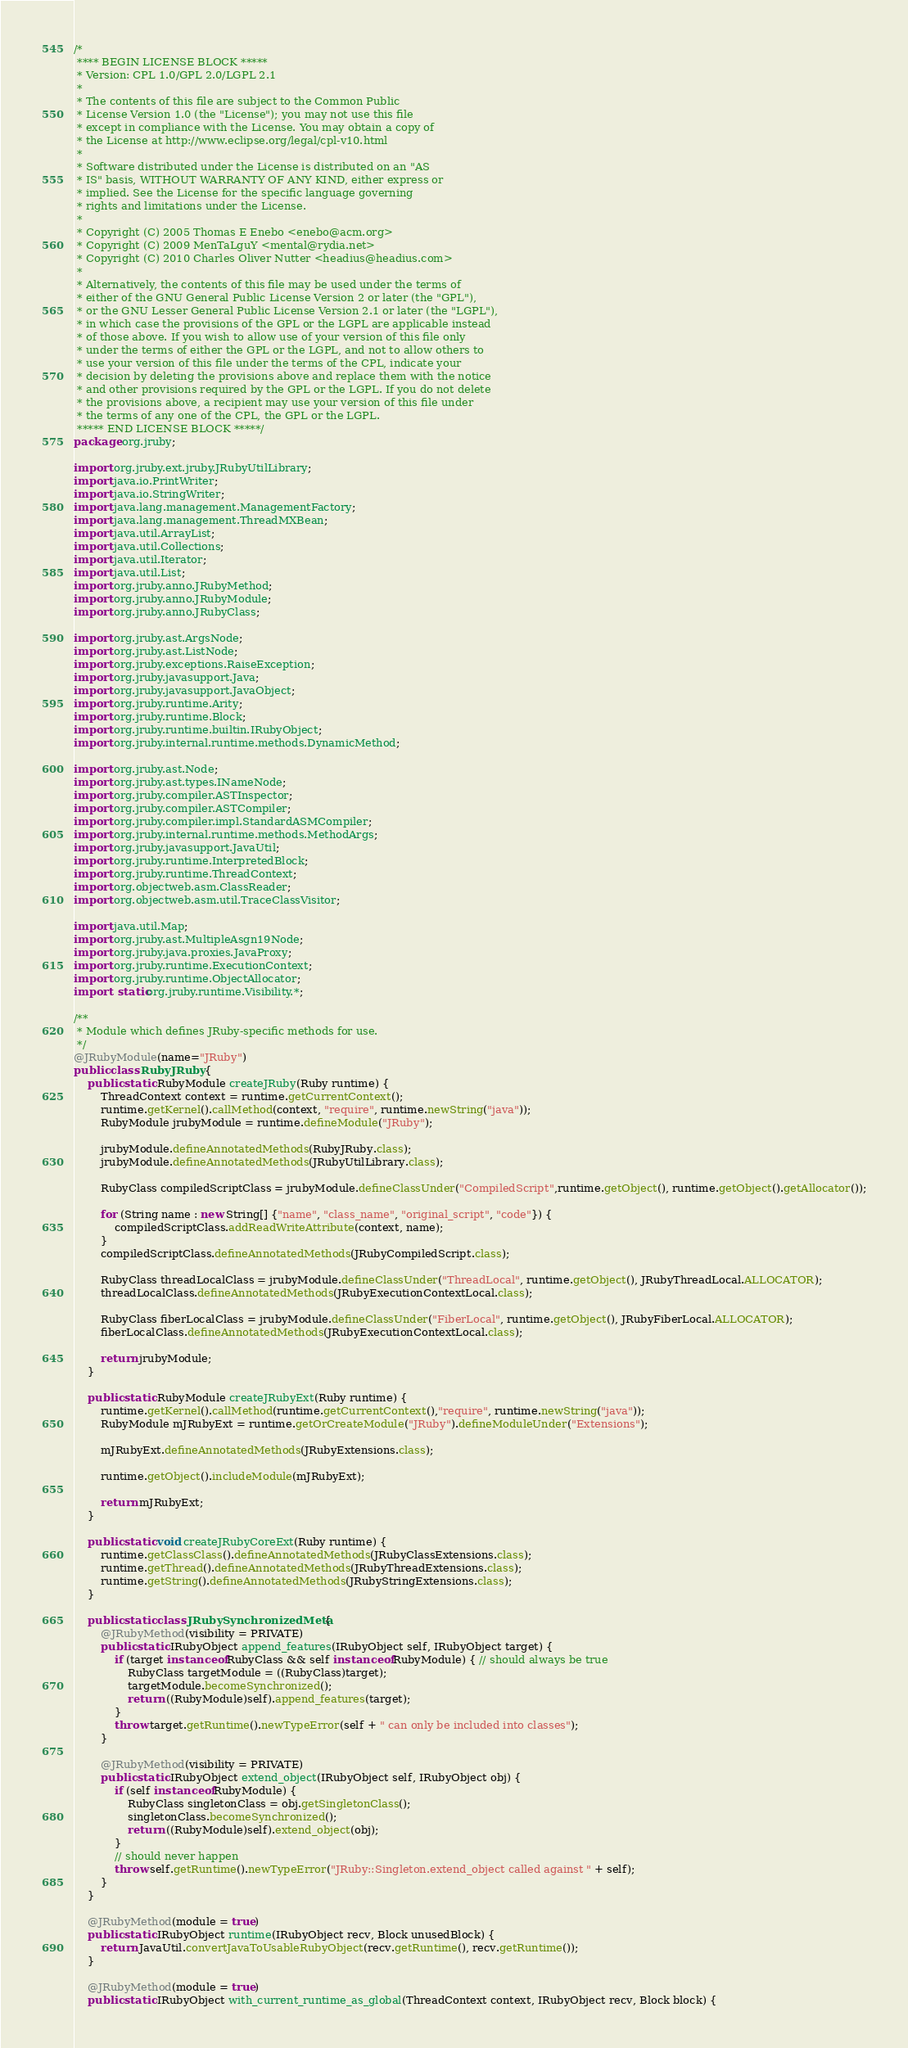Convert code to text. <code><loc_0><loc_0><loc_500><loc_500><_Java_>/*
 **** BEGIN LICENSE BLOCK *****
 * Version: CPL 1.0/GPL 2.0/LGPL 2.1
 *
 * The contents of this file are subject to the Common Public
 * License Version 1.0 (the "License"); you may not use this file
 * except in compliance with the License. You may obtain a copy of
 * the License at http://www.eclipse.org/legal/cpl-v10.html
 *
 * Software distributed under the License is distributed on an "AS
 * IS" basis, WITHOUT WARRANTY OF ANY KIND, either express or
 * implied. See the License for the specific language governing
 * rights and limitations under the License.
 *
 * Copyright (C) 2005 Thomas E Enebo <enebo@acm.org>
 * Copyright (C) 2009 MenTaLguY <mental@rydia.net>
 * Copyright (C) 2010 Charles Oliver Nutter <headius@headius.com>
 * 
 * Alternatively, the contents of this file may be used under the terms of
 * either of the GNU General Public License Version 2 or later (the "GPL"),
 * or the GNU Lesser General Public License Version 2.1 or later (the "LGPL"),
 * in which case the provisions of the GPL or the LGPL are applicable instead
 * of those above. If you wish to allow use of your version of this file only
 * under the terms of either the GPL or the LGPL, and not to allow others to
 * use your version of this file under the terms of the CPL, indicate your
 * decision by deleting the provisions above and replace them with the notice
 * and other provisions required by the GPL or the LGPL. If you do not delete
 * the provisions above, a recipient may use your version of this file under
 * the terms of any one of the CPL, the GPL or the LGPL.
 ***** END LICENSE BLOCK *****/
package org.jruby;

import org.jruby.ext.jruby.JRubyUtilLibrary;
import java.io.PrintWriter;
import java.io.StringWriter;
import java.lang.management.ManagementFactory;
import java.lang.management.ThreadMXBean;
import java.util.ArrayList;
import java.util.Collections;
import java.util.Iterator;
import java.util.List;
import org.jruby.anno.JRubyMethod;
import org.jruby.anno.JRubyModule;
import org.jruby.anno.JRubyClass;

import org.jruby.ast.ArgsNode;
import org.jruby.ast.ListNode;
import org.jruby.exceptions.RaiseException;
import org.jruby.javasupport.Java;
import org.jruby.javasupport.JavaObject;
import org.jruby.runtime.Arity;
import org.jruby.runtime.Block;
import org.jruby.runtime.builtin.IRubyObject;
import org.jruby.internal.runtime.methods.DynamicMethod;

import org.jruby.ast.Node;
import org.jruby.ast.types.INameNode;
import org.jruby.compiler.ASTInspector;
import org.jruby.compiler.ASTCompiler;
import org.jruby.compiler.impl.StandardASMCompiler;
import org.jruby.internal.runtime.methods.MethodArgs;
import org.jruby.javasupport.JavaUtil;
import org.jruby.runtime.InterpretedBlock;
import org.jruby.runtime.ThreadContext;
import org.objectweb.asm.ClassReader;
import org.objectweb.asm.util.TraceClassVisitor;

import java.util.Map;
import org.jruby.ast.MultipleAsgn19Node;
import org.jruby.java.proxies.JavaProxy;
import org.jruby.runtime.ExecutionContext;
import org.jruby.runtime.ObjectAllocator;
import static org.jruby.runtime.Visibility.*;

/**
 * Module which defines JRuby-specific methods for use. 
 */
@JRubyModule(name="JRuby")
public class RubyJRuby {
    public static RubyModule createJRuby(Ruby runtime) {
        ThreadContext context = runtime.getCurrentContext();
        runtime.getKernel().callMethod(context, "require", runtime.newString("java"));
        RubyModule jrubyModule = runtime.defineModule("JRuby");

        jrubyModule.defineAnnotatedMethods(RubyJRuby.class);
        jrubyModule.defineAnnotatedMethods(JRubyUtilLibrary.class);

        RubyClass compiledScriptClass = jrubyModule.defineClassUnder("CompiledScript",runtime.getObject(), runtime.getObject().getAllocator());

        for (String name : new String[] {"name", "class_name", "original_script", "code"}) {
            compiledScriptClass.addReadWriteAttribute(context, name);
        }
        compiledScriptClass.defineAnnotatedMethods(JRubyCompiledScript.class);

        RubyClass threadLocalClass = jrubyModule.defineClassUnder("ThreadLocal", runtime.getObject(), JRubyThreadLocal.ALLOCATOR);
        threadLocalClass.defineAnnotatedMethods(JRubyExecutionContextLocal.class);

        RubyClass fiberLocalClass = jrubyModule.defineClassUnder("FiberLocal", runtime.getObject(), JRubyFiberLocal.ALLOCATOR);
        fiberLocalClass.defineAnnotatedMethods(JRubyExecutionContextLocal.class);

        return jrubyModule;
    }

    public static RubyModule createJRubyExt(Ruby runtime) {
        runtime.getKernel().callMethod(runtime.getCurrentContext(),"require", runtime.newString("java"));
        RubyModule mJRubyExt = runtime.getOrCreateModule("JRuby").defineModuleUnder("Extensions");
        
        mJRubyExt.defineAnnotatedMethods(JRubyExtensions.class);

        runtime.getObject().includeModule(mJRubyExt);

        return mJRubyExt;
    }

    public static void createJRubyCoreExt(Ruby runtime) {
        runtime.getClassClass().defineAnnotatedMethods(JRubyClassExtensions.class);
        runtime.getThread().defineAnnotatedMethods(JRubyThreadExtensions.class);
        runtime.getString().defineAnnotatedMethods(JRubyStringExtensions.class);
    }

    public static class JRubySynchronizedMeta {
        @JRubyMethod(visibility = PRIVATE)
        public static IRubyObject append_features(IRubyObject self, IRubyObject target) {
            if (target instanceof RubyClass && self instanceof RubyModule) { // should always be true
                RubyClass targetModule = ((RubyClass)target);
                targetModule.becomeSynchronized();
                return ((RubyModule)self).append_features(target);
            }
            throw target.getRuntime().newTypeError(self + " can only be included into classes");
        }

        @JRubyMethod(visibility = PRIVATE)
        public static IRubyObject extend_object(IRubyObject self, IRubyObject obj) {
            if (self instanceof RubyModule) {
                RubyClass singletonClass = obj.getSingletonClass();
                singletonClass.becomeSynchronized();
                return ((RubyModule)self).extend_object(obj);
            }
            // should never happen
            throw self.getRuntime().newTypeError("JRuby::Singleton.extend_object called against " + self);
        }
    }

    @JRubyMethod(module = true)
    public static IRubyObject runtime(IRubyObject recv, Block unusedBlock) {
        return JavaUtil.convertJavaToUsableRubyObject(recv.getRuntime(), recv.getRuntime());
    }

    @JRubyMethod(module = true)
    public static IRubyObject with_current_runtime_as_global(ThreadContext context, IRubyObject recv, Block block) {</code> 